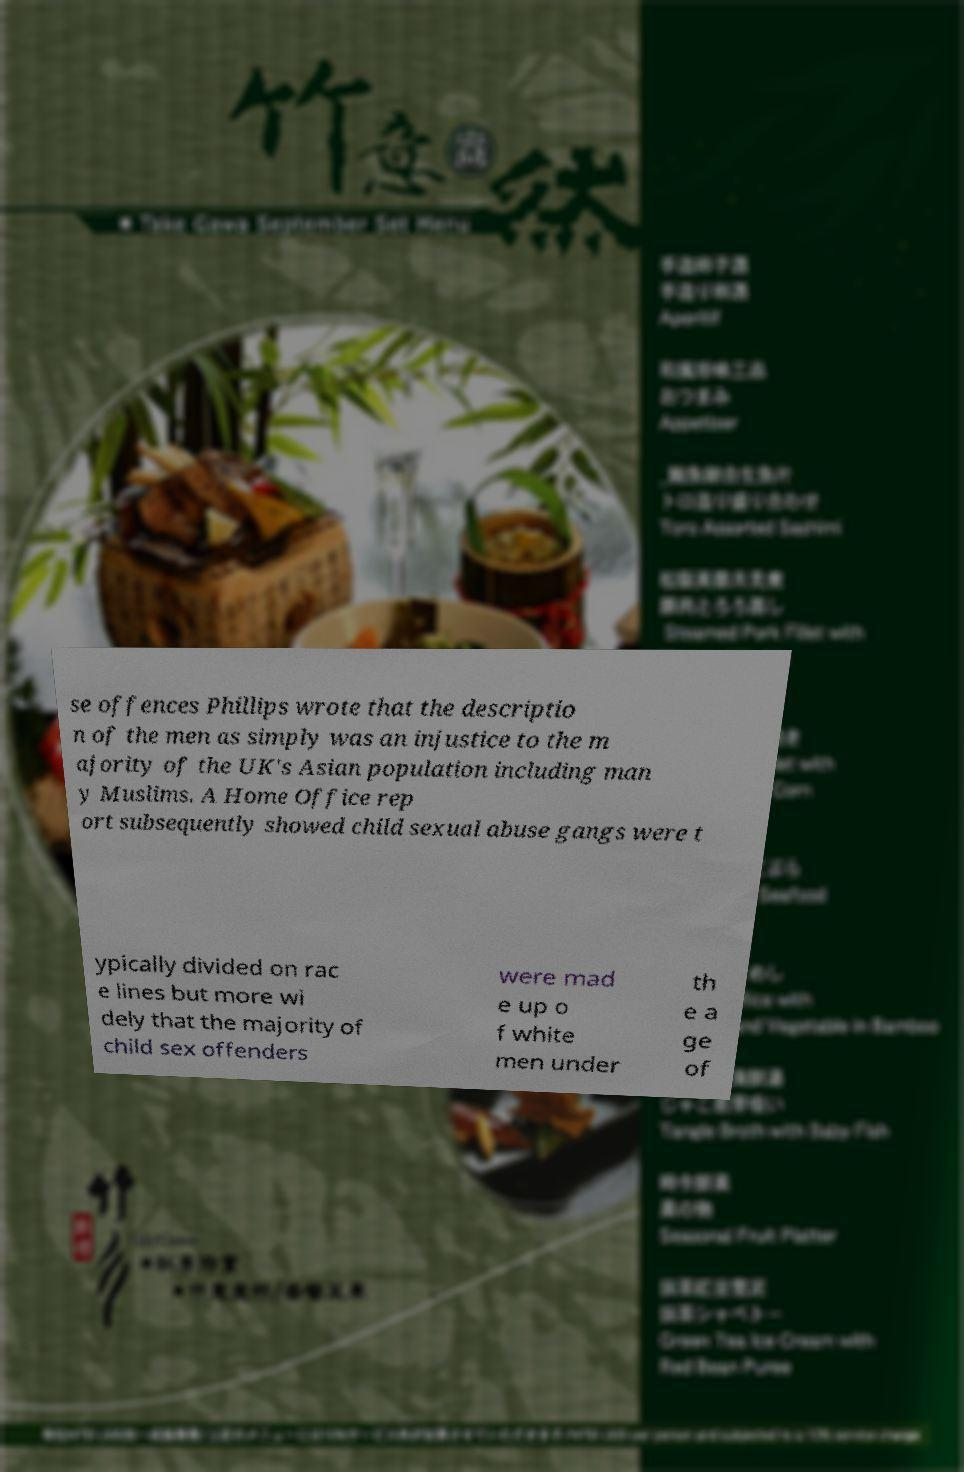Could you assist in decoding the text presented in this image and type it out clearly? se offences Phillips wrote that the descriptio n of the men as simply was an injustice to the m ajority of the UK's Asian population including man y Muslims. A Home Office rep ort subsequently showed child sexual abuse gangs were t ypically divided on rac e lines but more wi dely that the majority of child sex offenders were mad e up o f white men under th e a ge of 